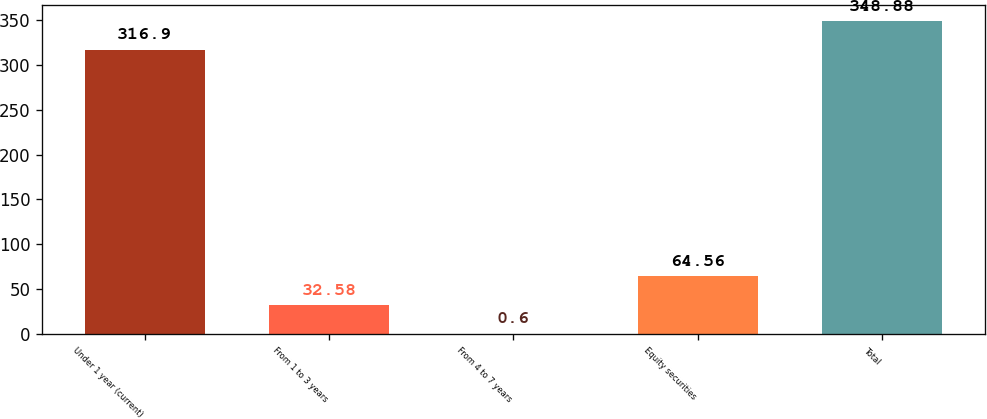Convert chart. <chart><loc_0><loc_0><loc_500><loc_500><bar_chart><fcel>Under 1 year (current)<fcel>From 1 to 3 years<fcel>From 4 to 7 years<fcel>Equity securities<fcel>Total<nl><fcel>316.9<fcel>32.58<fcel>0.6<fcel>64.56<fcel>348.88<nl></chart> 